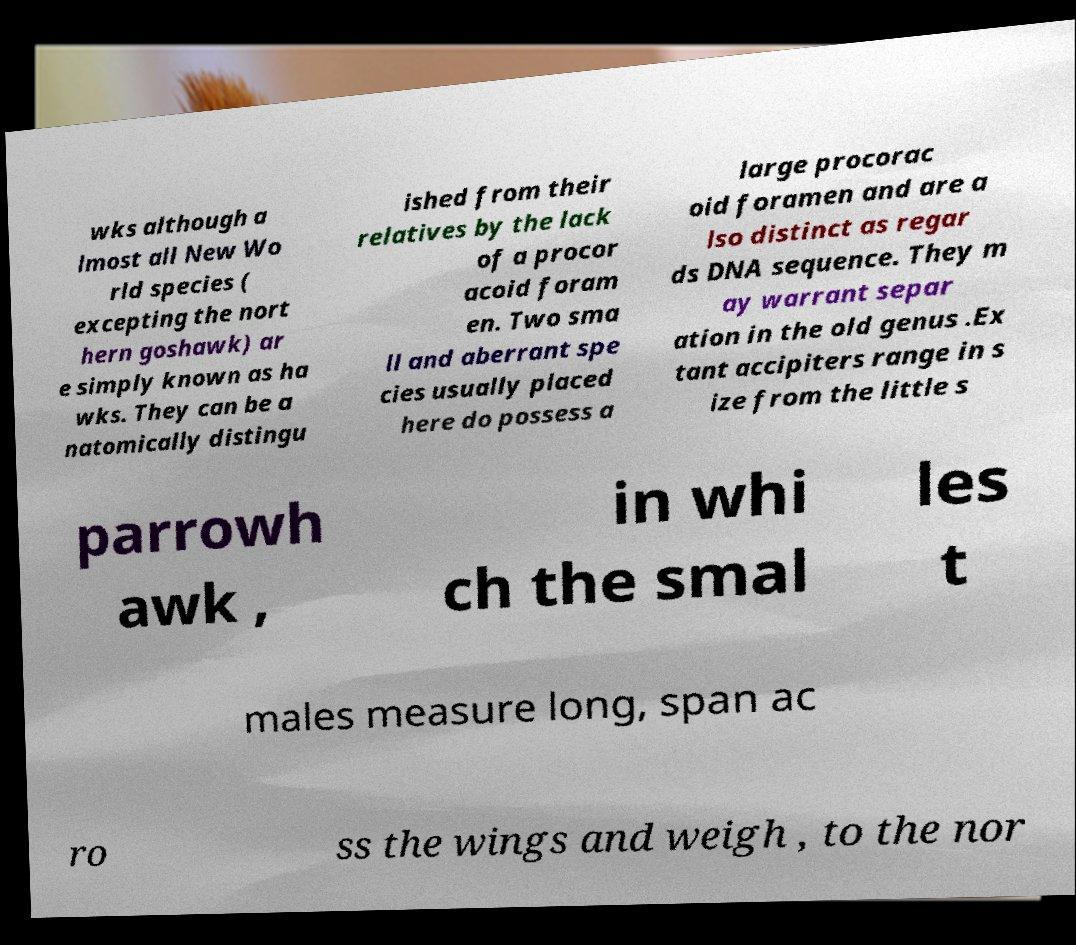For documentation purposes, I need the text within this image transcribed. Could you provide that? wks although a lmost all New Wo rld species ( excepting the nort hern goshawk) ar e simply known as ha wks. They can be a natomically distingu ished from their relatives by the lack of a procor acoid foram en. Two sma ll and aberrant spe cies usually placed here do possess a large procorac oid foramen and are a lso distinct as regar ds DNA sequence. They m ay warrant separ ation in the old genus .Ex tant accipiters range in s ize from the little s parrowh awk , in whi ch the smal les t males measure long, span ac ro ss the wings and weigh , to the nor 